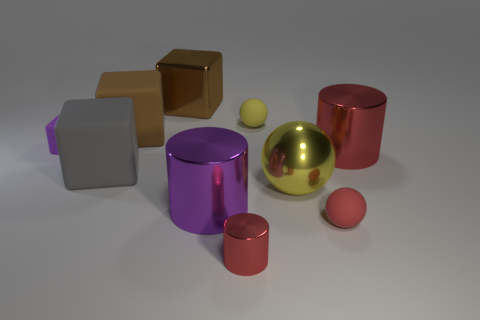Are there the same number of tiny yellow spheres that are behind the small cylinder and tiny yellow rubber balls?
Offer a terse response. Yes. How many other objects are there of the same size as the metal block?
Offer a very short reply. 5. Is the material of the big brown cube that is on the left side of the large brown metallic block the same as the small ball that is behind the red ball?
Give a very brief answer. Yes. There is a red thing in front of the tiny matte thing that is in front of the large purple cylinder; how big is it?
Provide a short and direct response. Small. Are there any metallic cylinders of the same color as the tiny block?
Your answer should be compact. Yes. Do the shiny cylinder right of the small red cylinder and the big shiny cylinder left of the small red metallic cylinder have the same color?
Make the answer very short. No. The large brown metallic object has what shape?
Your answer should be compact. Cube. There is a yellow shiny ball; what number of brown matte objects are left of it?
Your answer should be very brief. 1. What number of small cylinders have the same material as the large yellow sphere?
Offer a very short reply. 1. Are the small sphere in front of the tiny purple block and the large red thing made of the same material?
Provide a short and direct response. No. 